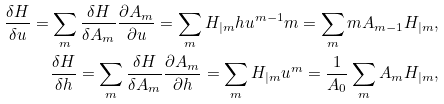<formula> <loc_0><loc_0><loc_500><loc_500>\frac { \delta H } { \delta u } = \sum _ { m } \frac { \delta H } { \delta A _ { m } } \frac { \partial A _ { m } } { \partial u } = \sum _ { m } H _ { | m } h u ^ { m - 1 } m = \sum _ { m } m A _ { m - 1 } H _ { | m } , \\ \frac { \delta H } { \delta h } = \sum _ { m } \frac { \delta H } { \delta A _ { m } } \frac { \partial A _ { m } } { \partial h } = \sum _ { m } H _ { | m } u ^ { m } = \frac { 1 } { A _ { 0 } } \sum _ { m } A _ { m } H _ { | m } ,</formula> 